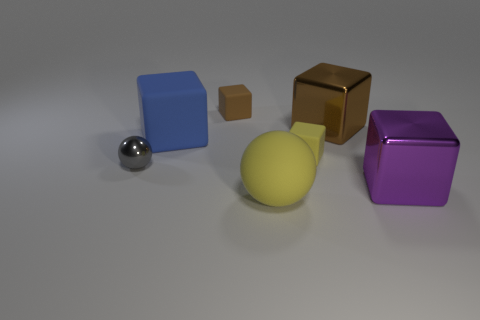Subtract all blue blocks. How many blocks are left? 4 Subtract all tiny brown blocks. How many blocks are left? 4 Subtract all cyan cubes. Subtract all purple spheres. How many cubes are left? 5 Add 1 gray balls. How many objects exist? 8 Subtract all cubes. How many objects are left? 2 Subtract 1 yellow blocks. How many objects are left? 6 Subtract all small rubber cubes. Subtract all metal objects. How many objects are left? 2 Add 7 tiny metallic things. How many tiny metallic things are left? 8 Add 3 yellow matte spheres. How many yellow matte spheres exist? 4 